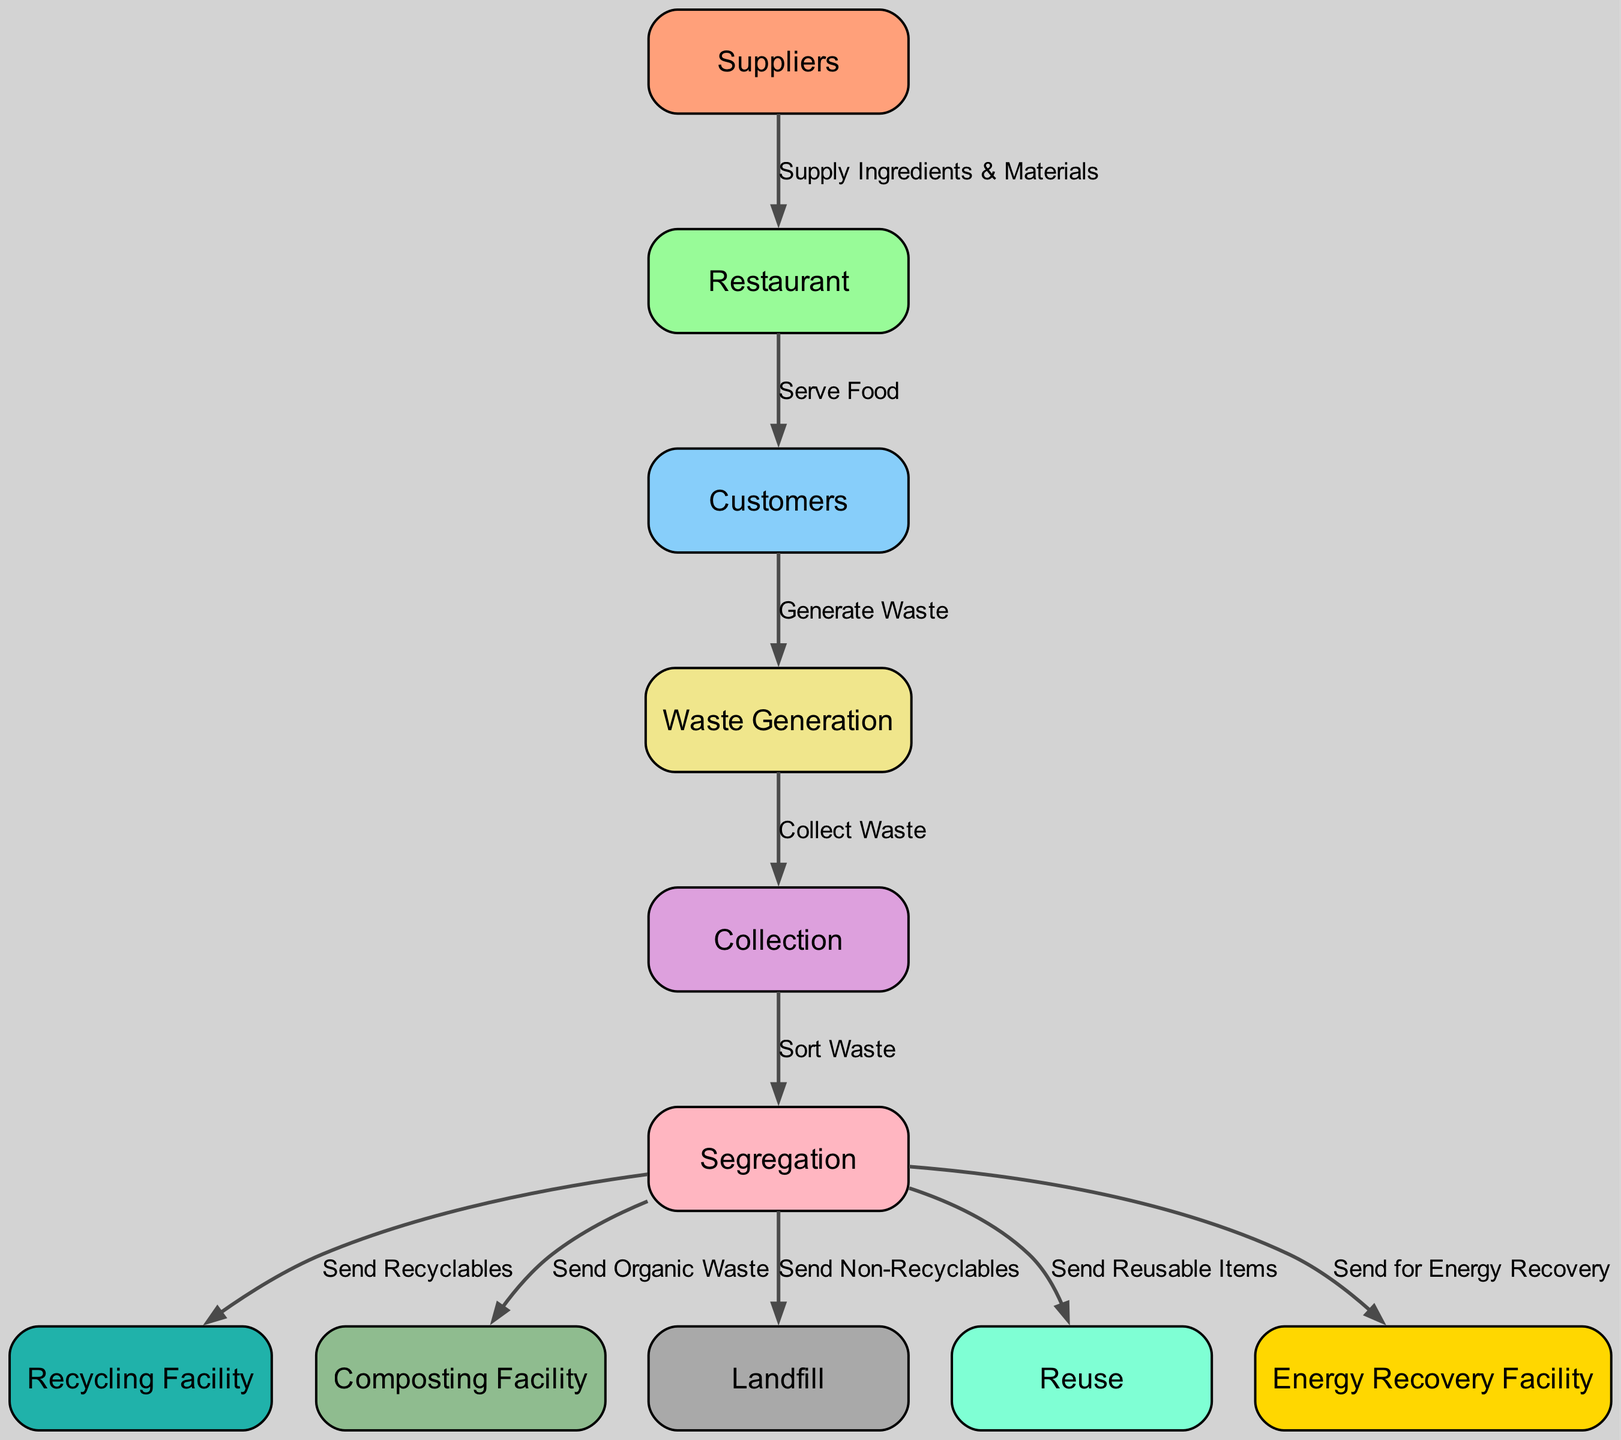What is the total number of nodes in the waste management system? The diagram lists the nodes clearly, and by counting them, there are ten distinct nodes representing different components in the waste management system.
Answer: ten Which node represents the generation of waste? In the diagram, the node titled "Waste Generation" directly identifies where waste is created, linking it to its related processes.
Answer: Waste Generation What do consumers generate in the fast food chain? According to the diagram, the relationship established between the consumers and the waste generation node indicates that consumers generate waste as part of their consumption process.
Answer: waste Which facility processes organic waste? The "Composting Facility" node in the diagram is specifically designated for the processing of organic waste, as indicated by the edge leading from the segregation node to the composting facility.
Answer: Composting Facility How many actions are taken after waste segregation? The diagram flows from the segregation node to five different facilities: recycling facility, composting facility, landfill, reuse and energy recovery facility. This indicates five possible actions taken after waste segregation.
Answer: five What color represents the recycling facility in the diagram? Each node in the diagram has a specific color, and the recycling facility is marked with a distinct shade of teal, specifically #20B2AA, which differentiates it from other facilities.
Answer: teal What is the process that happens after waste generation? Following the waste generation node in the diagram, the waste is collected, which leads to the next node, indicating the logical sequence in the waste management process.
Answer: collection Which nodes are the endpoints for non-recyclable waste? The diagram illustrates that non-recyclable waste is sent directly to the landfill node, making it clear that this is the final disposal method for non-recyclables.
Answer: landfill From which node do suppliers provide ingredients? The flow from the supplier node to the restaurant node shows that ingredients and materials are supplied to the restaurant for food preparation.
Answer: restaurant 